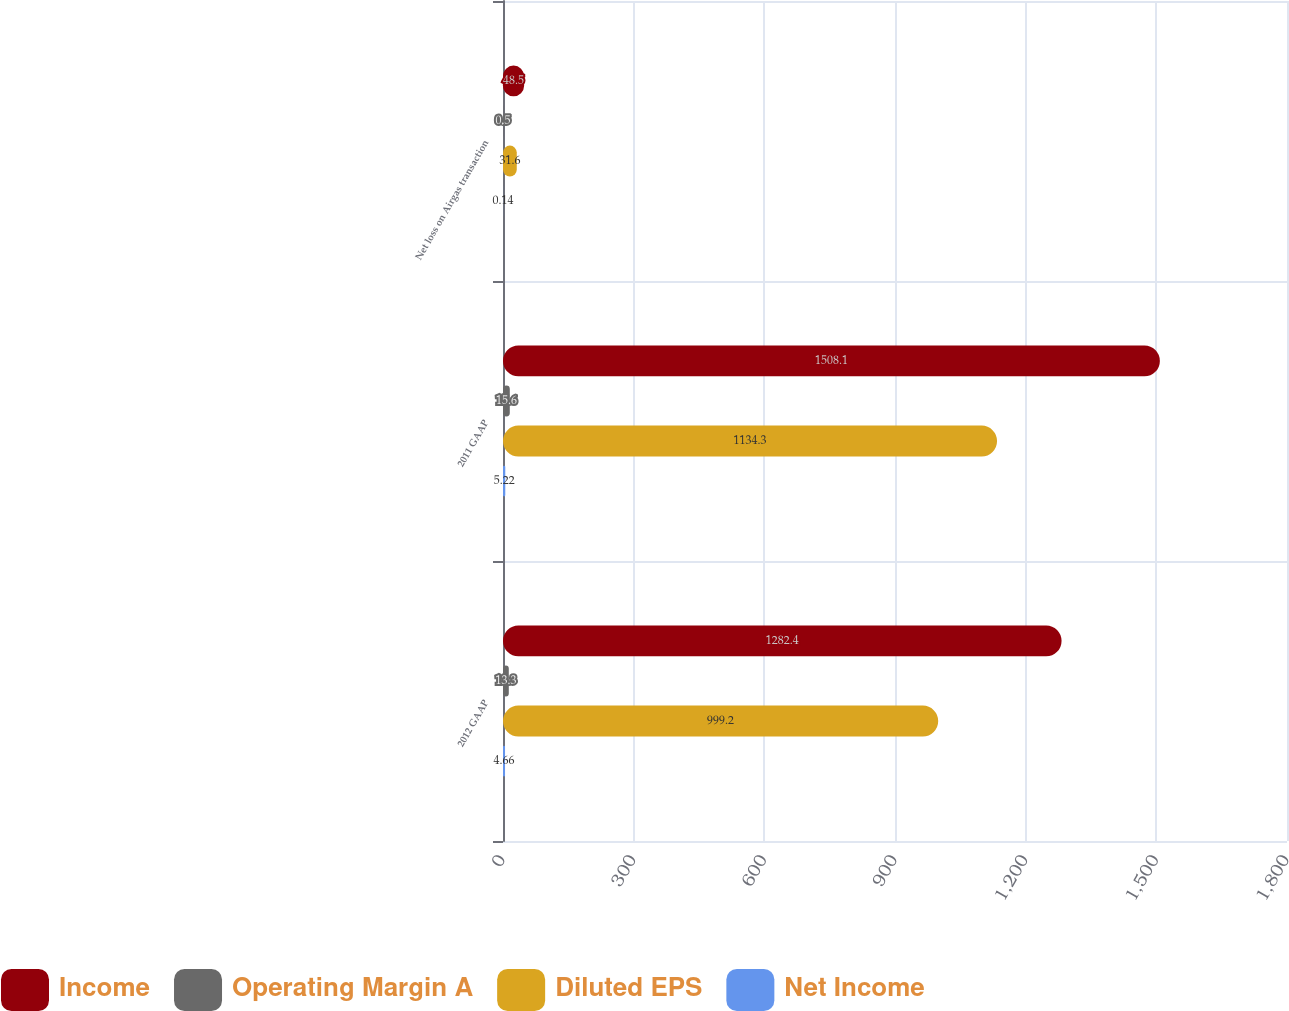Convert chart to OTSL. <chart><loc_0><loc_0><loc_500><loc_500><stacked_bar_chart><ecel><fcel>2012 GAAP<fcel>2011 GAAP<fcel>Net loss on Airgas transaction<nl><fcel>Income<fcel>1282.4<fcel>1508.1<fcel>48.5<nl><fcel>Operating Margin A<fcel>13.3<fcel>15.6<fcel>0.5<nl><fcel>Diluted EPS<fcel>999.2<fcel>1134.3<fcel>31.6<nl><fcel>Net Income<fcel>4.66<fcel>5.22<fcel>0.14<nl></chart> 